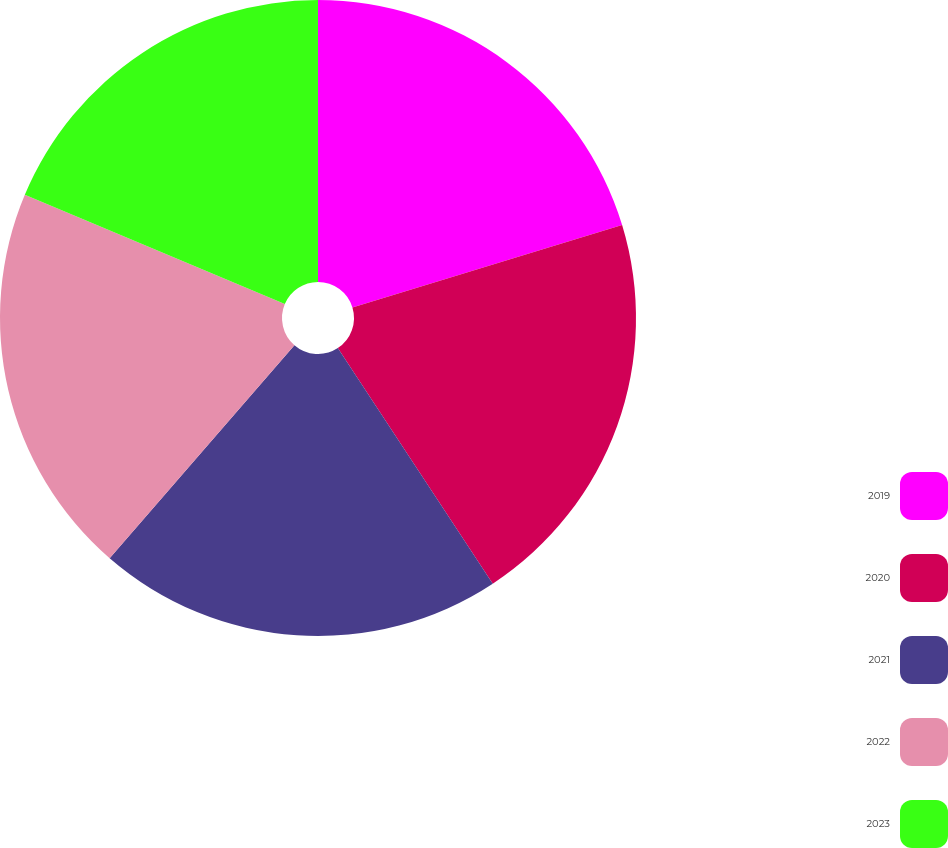<chart> <loc_0><loc_0><loc_500><loc_500><pie_chart><fcel>2019<fcel>2020<fcel>2021<fcel>2022<fcel>2023<nl><fcel>20.28%<fcel>20.46%<fcel>20.63%<fcel>19.96%<fcel>18.67%<nl></chart> 